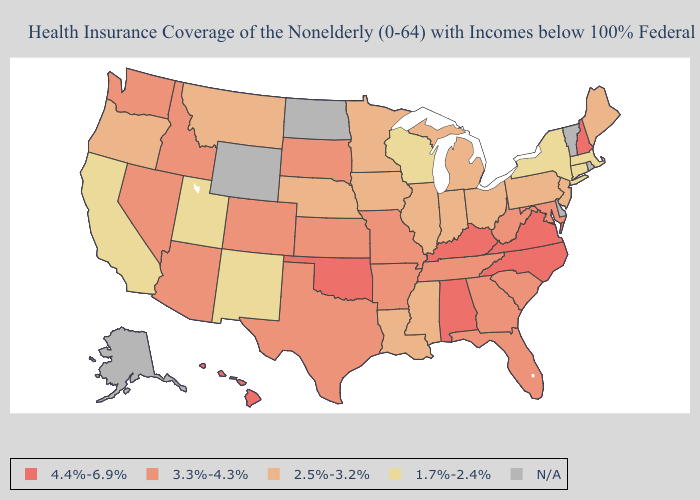What is the highest value in states that border Maine?
Write a very short answer. 4.4%-6.9%. What is the highest value in states that border Minnesota?
Write a very short answer. 3.3%-4.3%. What is the highest value in the USA?
Keep it brief. 4.4%-6.9%. Which states hav the highest value in the MidWest?
Be succinct. Kansas, Missouri, South Dakota. What is the highest value in states that border Missouri?
Short answer required. 4.4%-6.9%. What is the value of Maine?
Give a very brief answer. 2.5%-3.2%. Among the states that border Pennsylvania , which have the lowest value?
Give a very brief answer. New York. Among the states that border Idaho , does Utah have the lowest value?
Concise answer only. Yes. What is the value of Rhode Island?
Short answer required. N/A. What is the value of Tennessee?
Concise answer only. 3.3%-4.3%. What is the highest value in the West ?
Answer briefly. 4.4%-6.9%. Name the states that have a value in the range N/A?
Keep it brief. Alaska, Delaware, North Dakota, Rhode Island, Vermont, Wyoming. What is the value of Wisconsin?
Give a very brief answer. 1.7%-2.4%. Does Hawaii have the lowest value in the USA?
Answer briefly. No. Does the first symbol in the legend represent the smallest category?
Write a very short answer. No. 